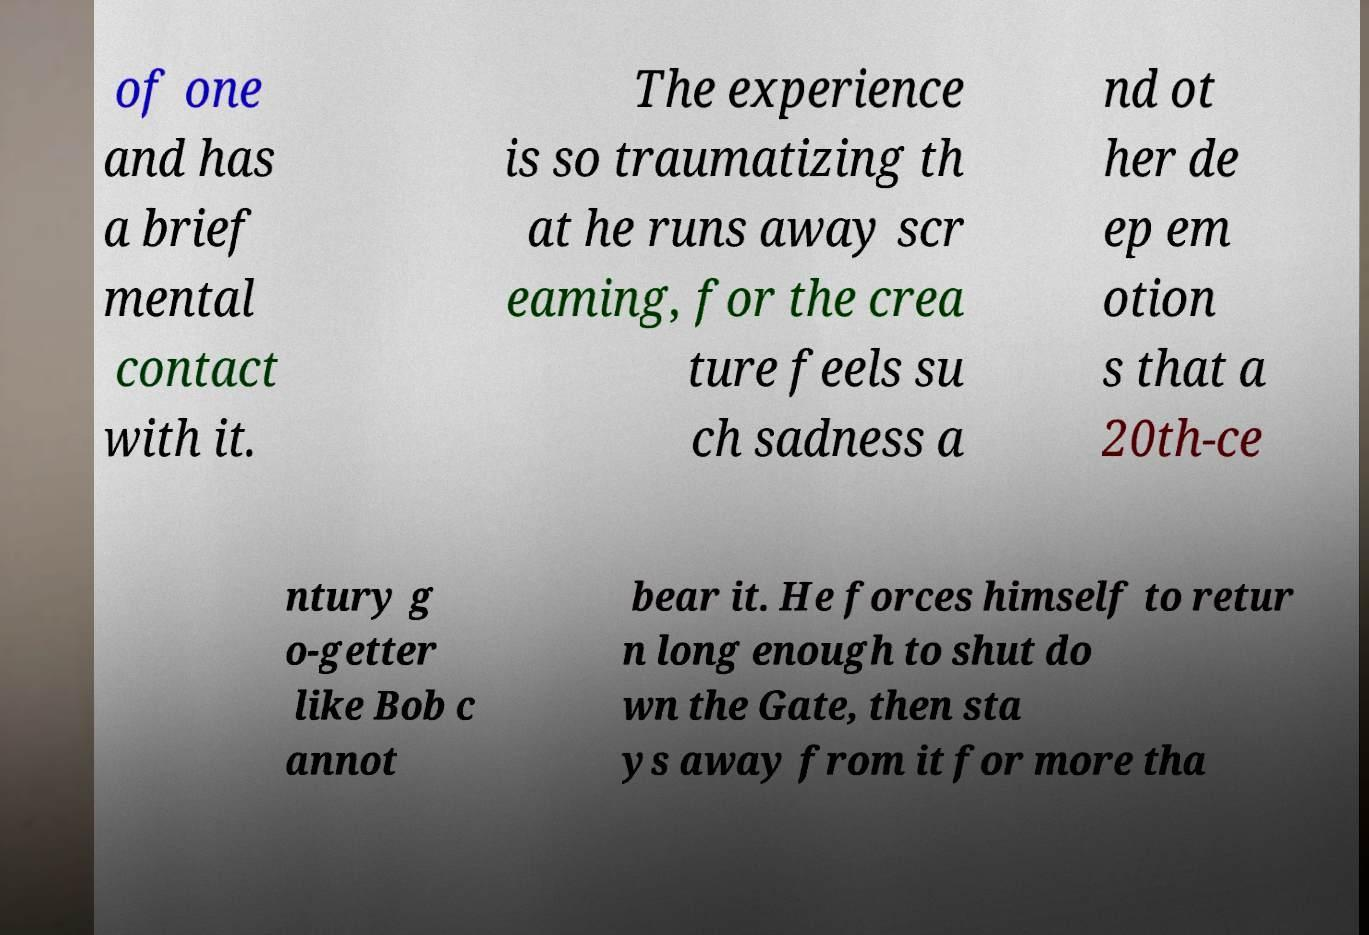There's text embedded in this image that I need extracted. Can you transcribe it verbatim? of one and has a brief mental contact with it. The experience is so traumatizing th at he runs away scr eaming, for the crea ture feels su ch sadness a nd ot her de ep em otion s that a 20th-ce ntury g o-getter like Bob c annot bear it. He forces himself to retur n long enough to shut do wn the Gate, then sta ys away from it for more tha 